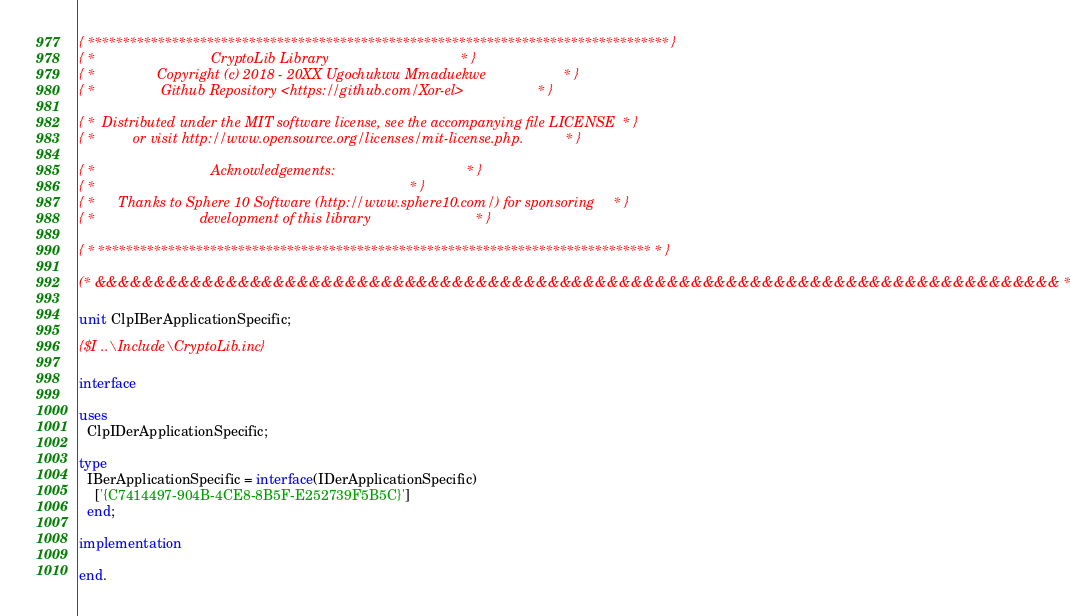Convert code to text. <code><loc_0><loc_0><loc_500><loc_500><_Pascal_>{ *********************************************************************************** }
{ *                              CryptoLib Library                                  * }
{ *                Copyright (c) 2018 - 20XX Ugochukwu Mmaduekwe                    * }
{ *                 Github Repository <https://github.com/Xor-el>                   * }

{ *  Distributed under the MIT software license, see the accompanying file LICENSE  * }
{ *          or visit http://www.opensource.org/licenses/mit-license.php.           * }

{ *                              Acknowledgements:                                  * }
{ *                                                                                 * }
{ *      Thanks to Sphere 10 Software (http://www.sphere10.com/) for sponsoring     * }
{ *                           development of this library                           * }

{ * ******************************************************************************* * }

(* &&&&&&&&&&&&&&&&&&&&&&&&&&&&&&&&&&&&&&&&&&&&&&&&&&&&&&&&&&&&&&&&&&&&&&&&&&&&&&&&& *)

unit ClpIBerApplicationSpecific;

{$I ..\Include\CryptoLib.inc}

interface

uses
  ClpIDerApplicationSpecific;

type
  IBerApplicationSpecific = interface(IDerApplicationSpecific)
    ['{C7414497-904B-4CE8-8B5F-E252739F5B5C}']
  end;

implementation

end.
</code> 